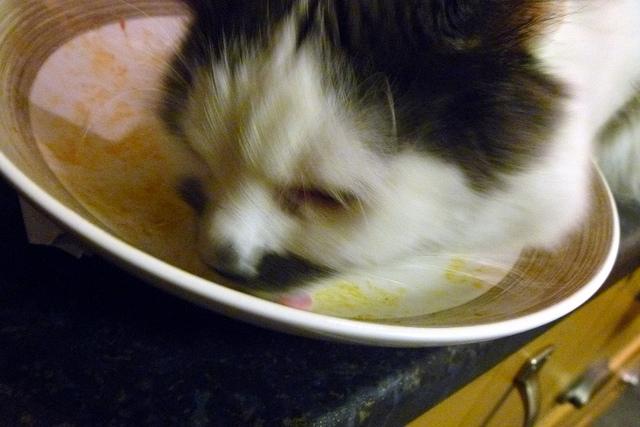Is this photo blurry?
Quick response, please. Yes. Is the cat's nose messy?
Be succinct. Yes. What is in the bowl?
Answer briefly. Food. Why is the cat putting its head in the glass?
Keep it brief. Eating. 